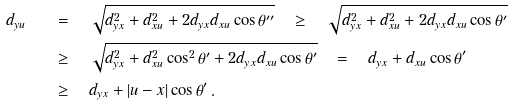<formula> <loc_0><loc_0><loc_500><loc_500>d _ { y u } \quad & = \quad \sqrt { d _ { y x } ^ { 2 } + d _ { x u } ^ { 2 } + 2 d _ { y x } d _ { x u } \cos \theta ^ { \prime \prime } } \quad \geq \quad \sqrt { d _ { y x } ^ { 2 } + d _ { x u } ^ { 2 } + 2 d _ { y x } d _ { x u } \cos \theta ^ { \prime } } \\ & \geq \quad \sqrt { d _ { y x } ^ { 2 } + d _ { x u } ^ { 2 } \cos ^ { 2 } \theta ^ { \prime } + 2 d _ { y x } d _ { x u } \cos \theta ^ { \prime } } \quad = \quad d _ { y x } + d _ { x u } \cos \theta ^ { \prime } \\ & \geq \quad d _ { y x } + | u - x | \cos \theta ^ { \prime } \, .</formula> 